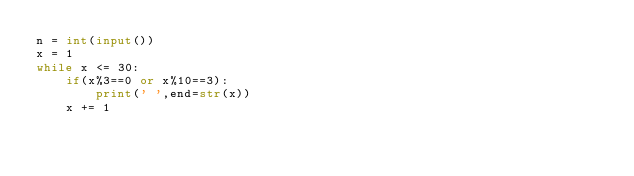Convert code to text. <code><loc_0><loc_0><loc_500><loc_500><_Python_>n = int(input())
x = 1
while x <= 30:
    if(x%3==0 or x%10==3):
        print(' ',end=str(x))
    x += 1

</code> 